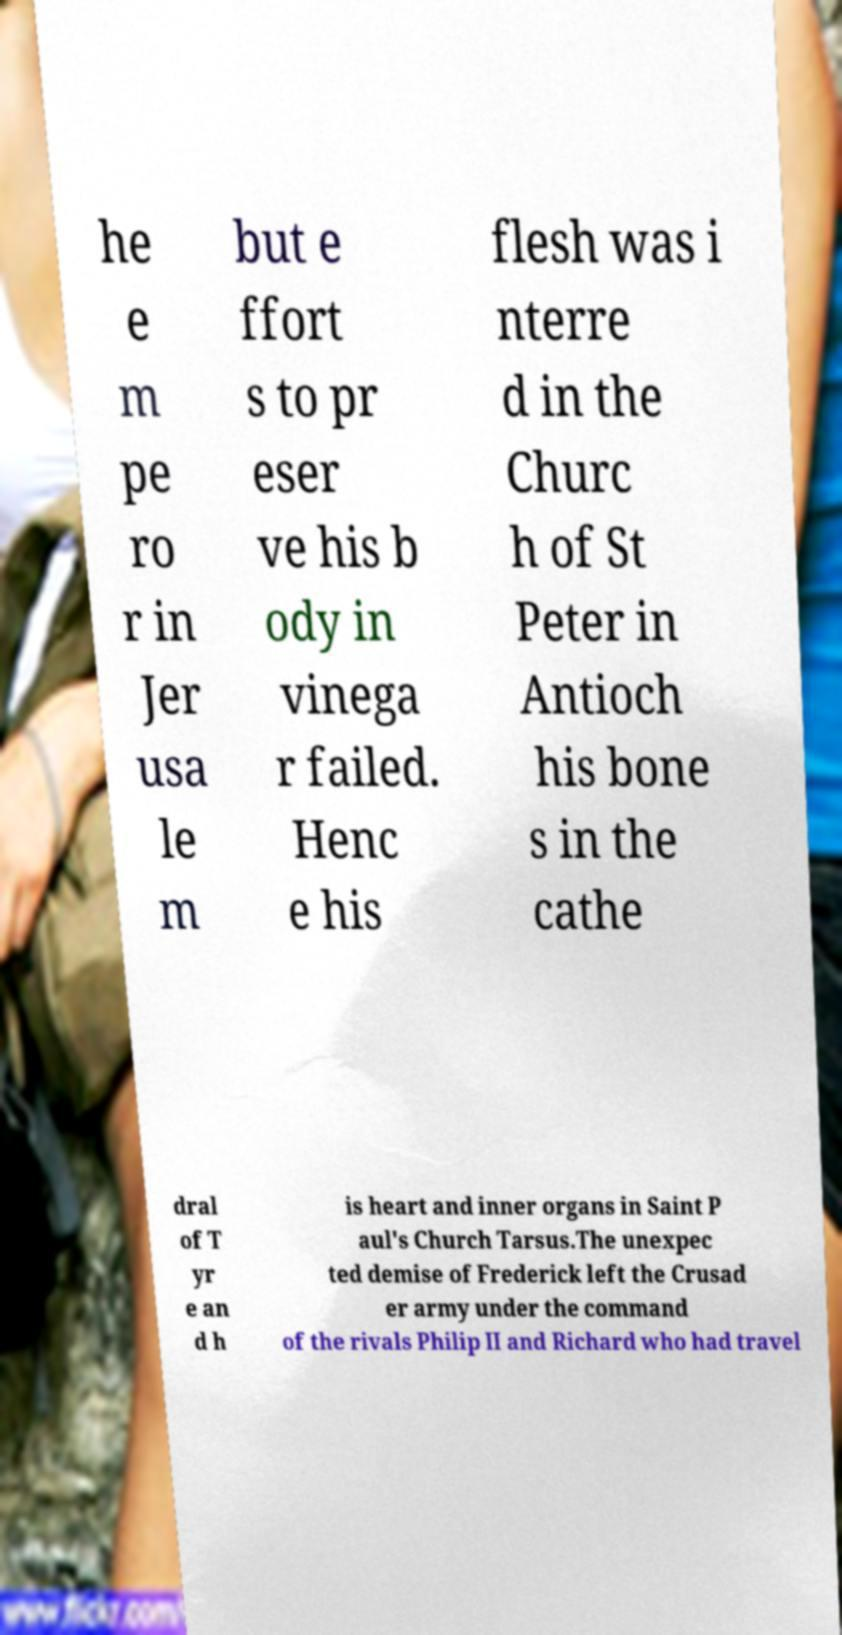For documentation purposes, I need the text within this image transcribed. Could you provide that? he e m pe ro r in Jer usa le m but e ffort s to pr eser ve his b ody in vinega r failed. Henc e his flesh was i nterre d in the Churc h of St Peter in Antioch his bone s in the cathe dral of T yr e an d h is heart and inner organs in Saint P aul's Church Tarsus.The unexpec ted demise of Frederick left the Crusad er army under the command of the rivals Philip II and Richard who had travel 